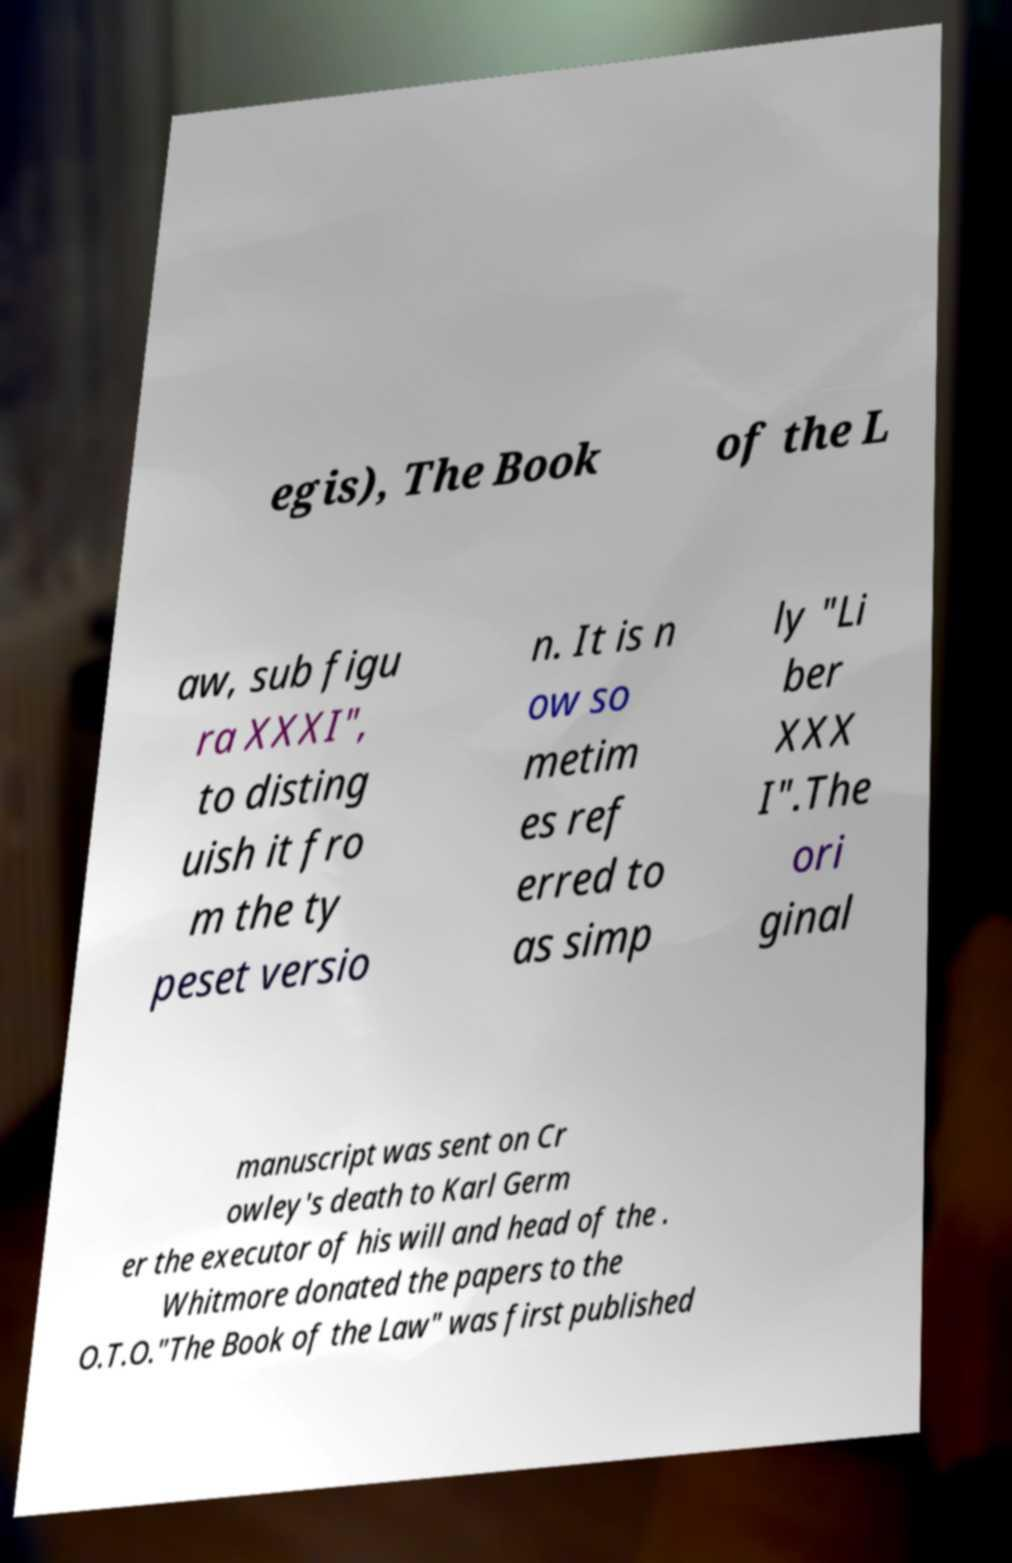Can you accurately transcribe the text from the provided image for me? egis), The Book of the L aw, sub figu ra XXXI", to disting uish it fro m the ty peset versio n. It is n ow so metim es ref erred to as simp ly "Li ber XXX I".The ori ginal manuscript was sent on Cr owley's death to Karl Germ er the executor of his will and head of the . Whitmore donated the papers to the O.T.O."The Book of the Law" was first published 